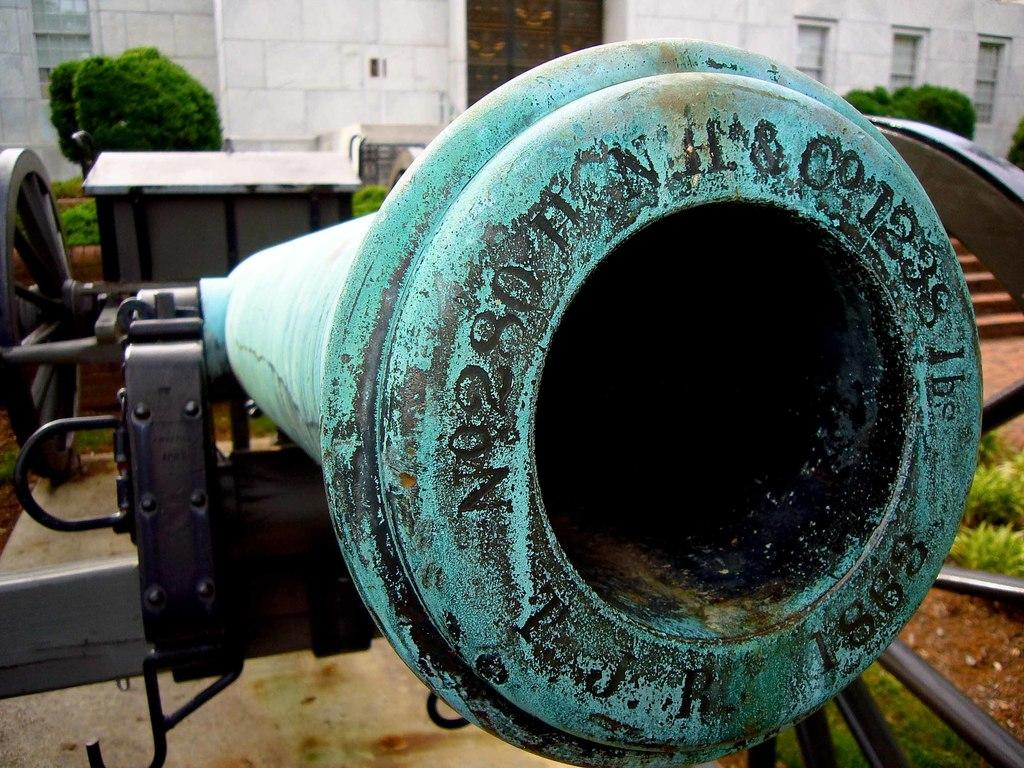What is the main object in the image? There is a green color canon in the image. Where is the canon located in relation to the image? The canon is in the front of the image. What can be seen in the background of the image? There is a white color building wall and green plants in the background of the image. What type of stone is used to make the cakes in the image? There are no cakes present in the image, so it is not possible to determine the type of stone used to make them. 